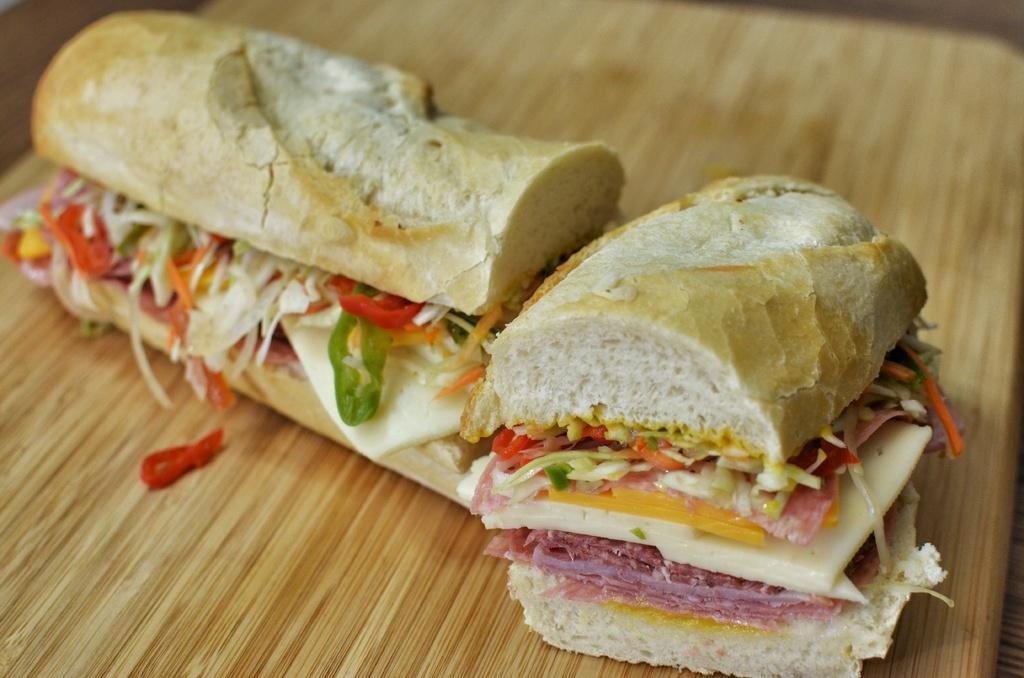What type of food is shown in the image? There are two slices of burger in the image. Where are the burger slices placed? The burger slices are on a wooden board. What does the kitten say to the girl as they walk away from the burger in the image? There is no kitten or girl present in the image, so this scenario cannot be observed. 